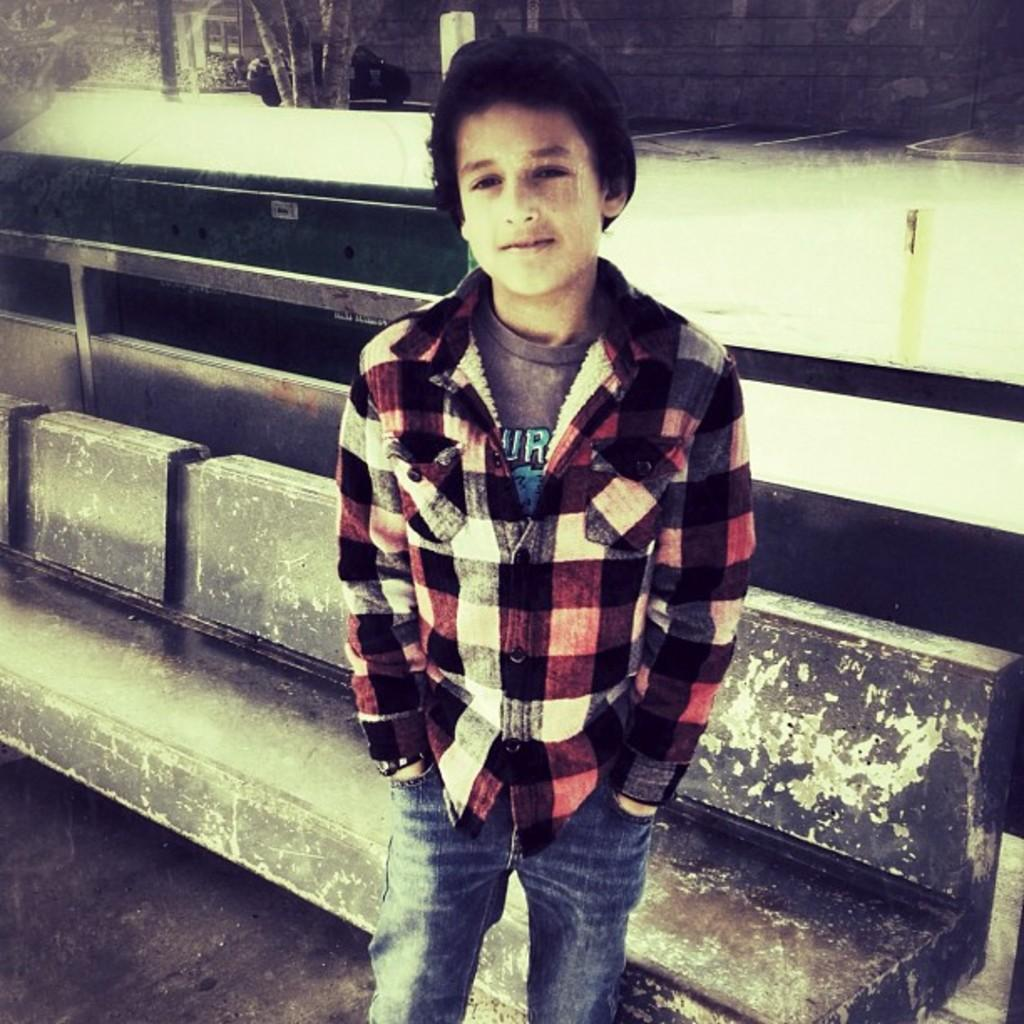What is the main subject of the image? There is a person standing in the image. Can you describe the person's expression? The person is smiling. What can be seen in the background of the image? There is snow in the background of the image. Where is the goldfish located in the image? There is no goldfish present in the image. What color are the person's eyes in the image? The provided facts do not mention the color of the person's eyes, so we cannot determine that information from the image. 